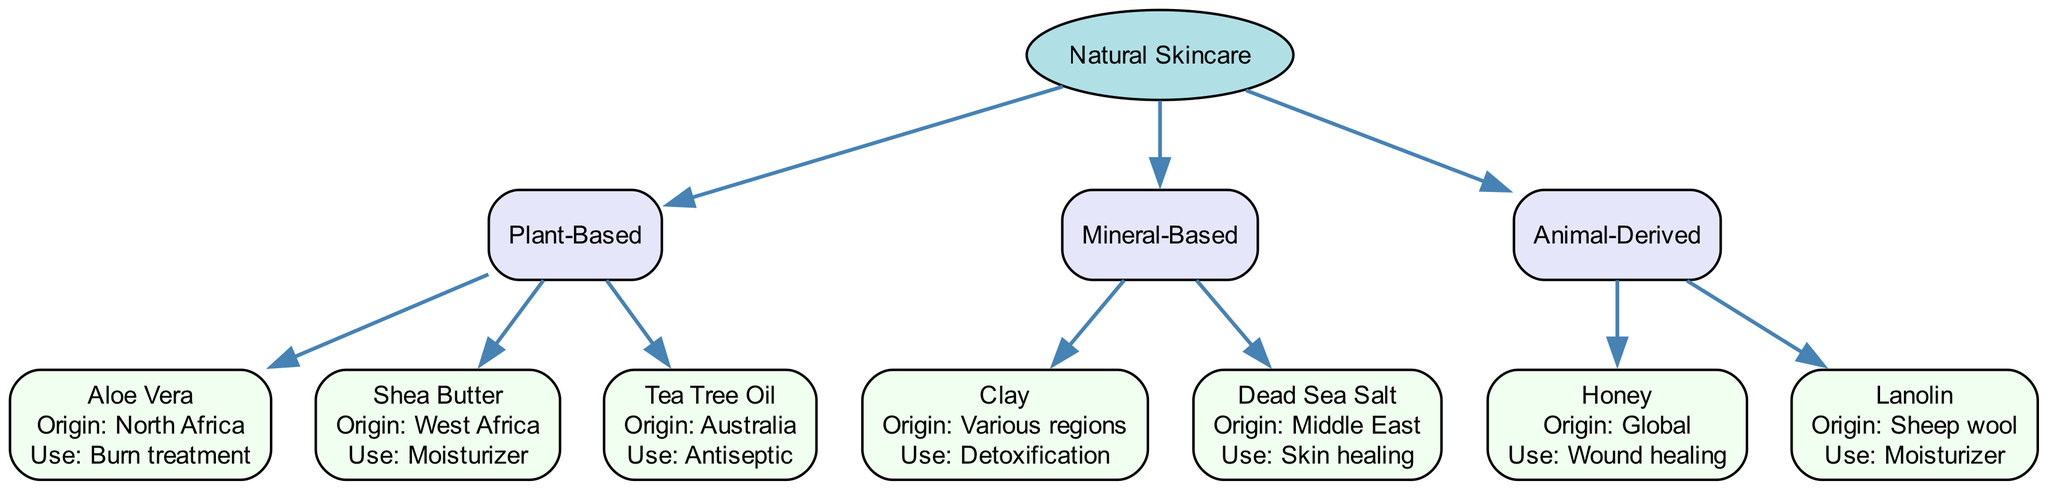What are the main categories of natural skincare ingredients? The diagram has three main categories branching out from the "Natural Skincare" node: "Plant-Based," "Mineral-Based," and "Animal-Derived."
Answer: Plant-Based, Mineral-Based, Animal-Derived How many plant-based ingredients are listed? The diagram displays three ingredients under the "Plant-Based" category: "Aloe Vera," "Shea Butter," and "Tea Tree Oil." Thus, the total is three.
Answer: 3 What is the traditional use of Shea Butter? The information shows that Shea Butter’s traditional use, as indicated next to the ingredient node, is "Moisturizer."
Answer: Moisturizer Which ingredient has its origin listed as "North Africa"? The node for "Aloe Vera" states that its origin is "North Africa," as seen in the ingredient label connected to the "Plant-Based" category.
Answer: Aloe Vera What traditional use is associated with Dead Sea Salt? The Dead Sea Salt node specifically states its traditional use as "Skin healing," which can be found under the "Mineral-Based" category.
Answer: Skin healing Which category does Honey belong to? Honey is listed under the "Animal-Derived" category in the diagram, highlighting the connection between ingredients and their respective classifications.
Answer: Animal-Derived Are there more mineral-based ingredients or plant-based ingredients? The diagram shows three ingredients under "Plant-Based" and two under "Mineral-Based." Comparing these counts shows that there are more plant-based ingredients.
Answer: Plant-based How many different origins are mentioned for the ingredients? The origins for the listed ingredients are: "North Africa," "West Africa," "Australia," "Various regions," "Middle East," and "Global," leading to a total of six distinct origins in the chart.
Answer: 6 What is the traditional use of Clay? The diagram indicates that Clay's traditional use is "Detoxification," which is directly cited in the label associated with the Clay node under "Mineral-Based."
Answer: Detoxification 